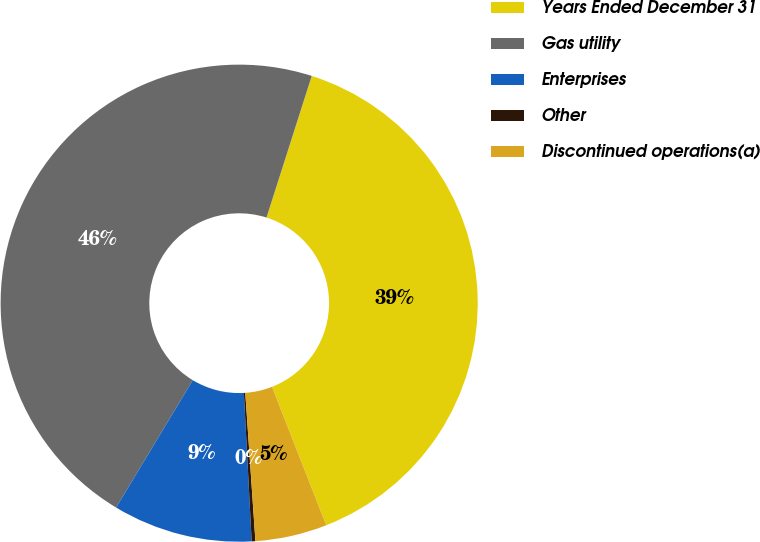Convert chart to OTSL. <chart><loc_0><loc_0><loc_500><loc_500><pie_chart><fcel>Years Ended December 31<fcel>Gas utility<fcel>Enterprises<fcel>Other<fcel>Discontinued operations(a)<nl><fcel>39.13%<fcel>46.29%<fcel>9.46%<fcel>0.25%<fcel>4.86%<nl></chart> 